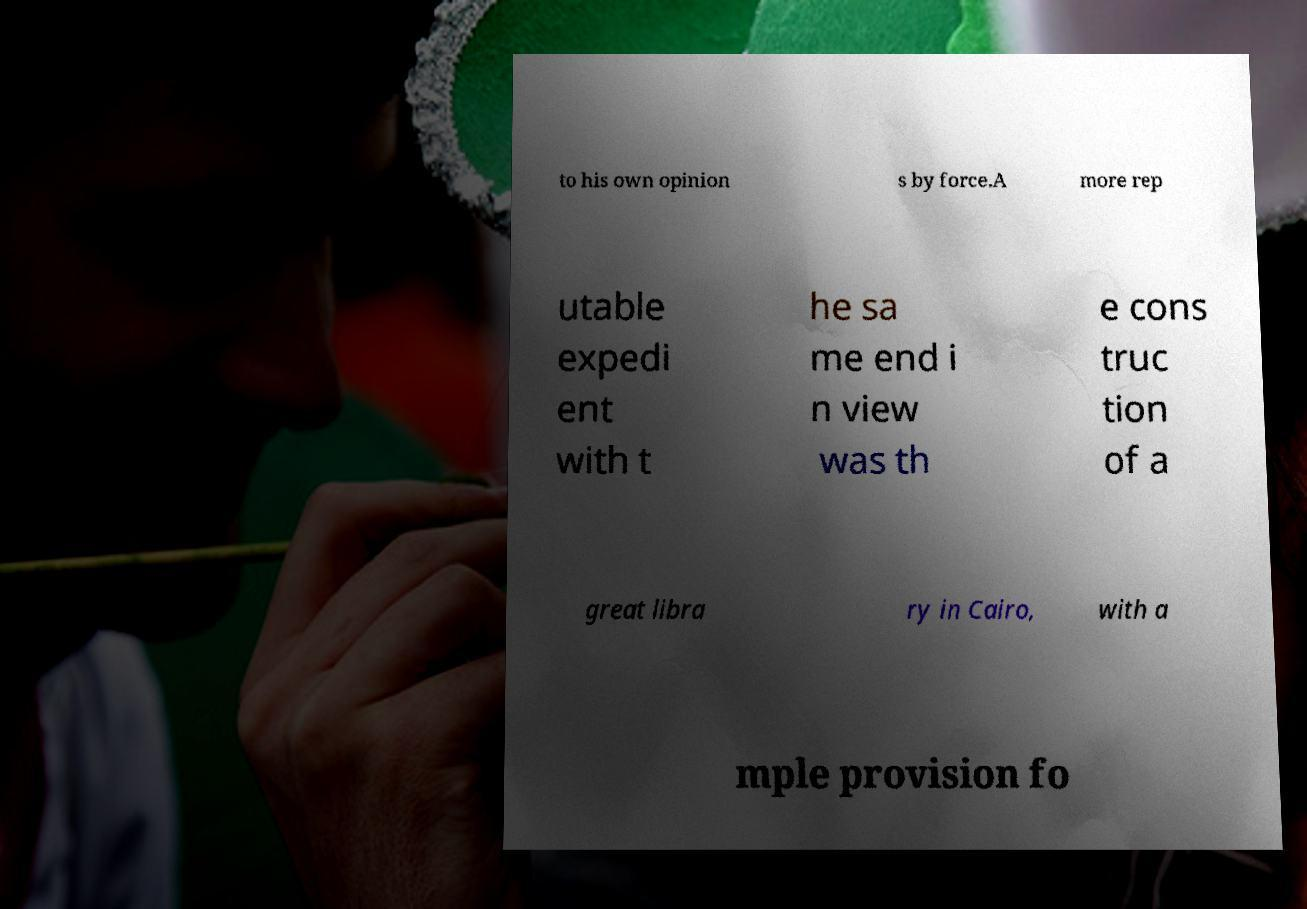Please read and relay the text visible in this image. What does it say? to his own opinion s by force.A more rep utable expedi ent with t he sa me end i n view was th e cons truc tion of a great libra ry in Cairo, with a mple provision fo 